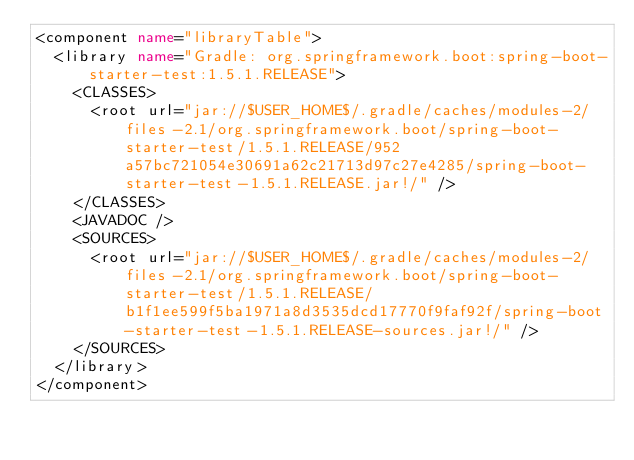Convert code to text. <code><loc_0><loc_0><loc_500><loc_500><_XML_><component name="libraryTable">
  <library name="Gradle: org.springframework.boot:spring-boot-starter-test:1.5.1.RELEASE">
    <CLASSES>
      <root url="jar://$USER_HOME$/.gradle/caches/modules-2/files-2.1/org.springframework.boot/spring-boot-starter-test/1.5.1.RELEASE/952a57bc721054e30691a62c21713d97c27e4285/spring-boot-starter-test-1.5.1.RELEASE.jar!/" />
    </CLASSES>
    <JAVADOC />
    <SOURCES>
      <root url="jar://$USER_HOME$/.gradle/caches/modules-2/files-2.1/org.springframework.boot/spring-boot-starter-test/1.5.1.RELEASE/b1f1ee599f5ba1971a8d3535dcd17770f9faf92f/spring-boot-starter-test-1.5.1.RELEASE-sources.jar!/" />
    </SOURCES>
  </library>
</component></code> 